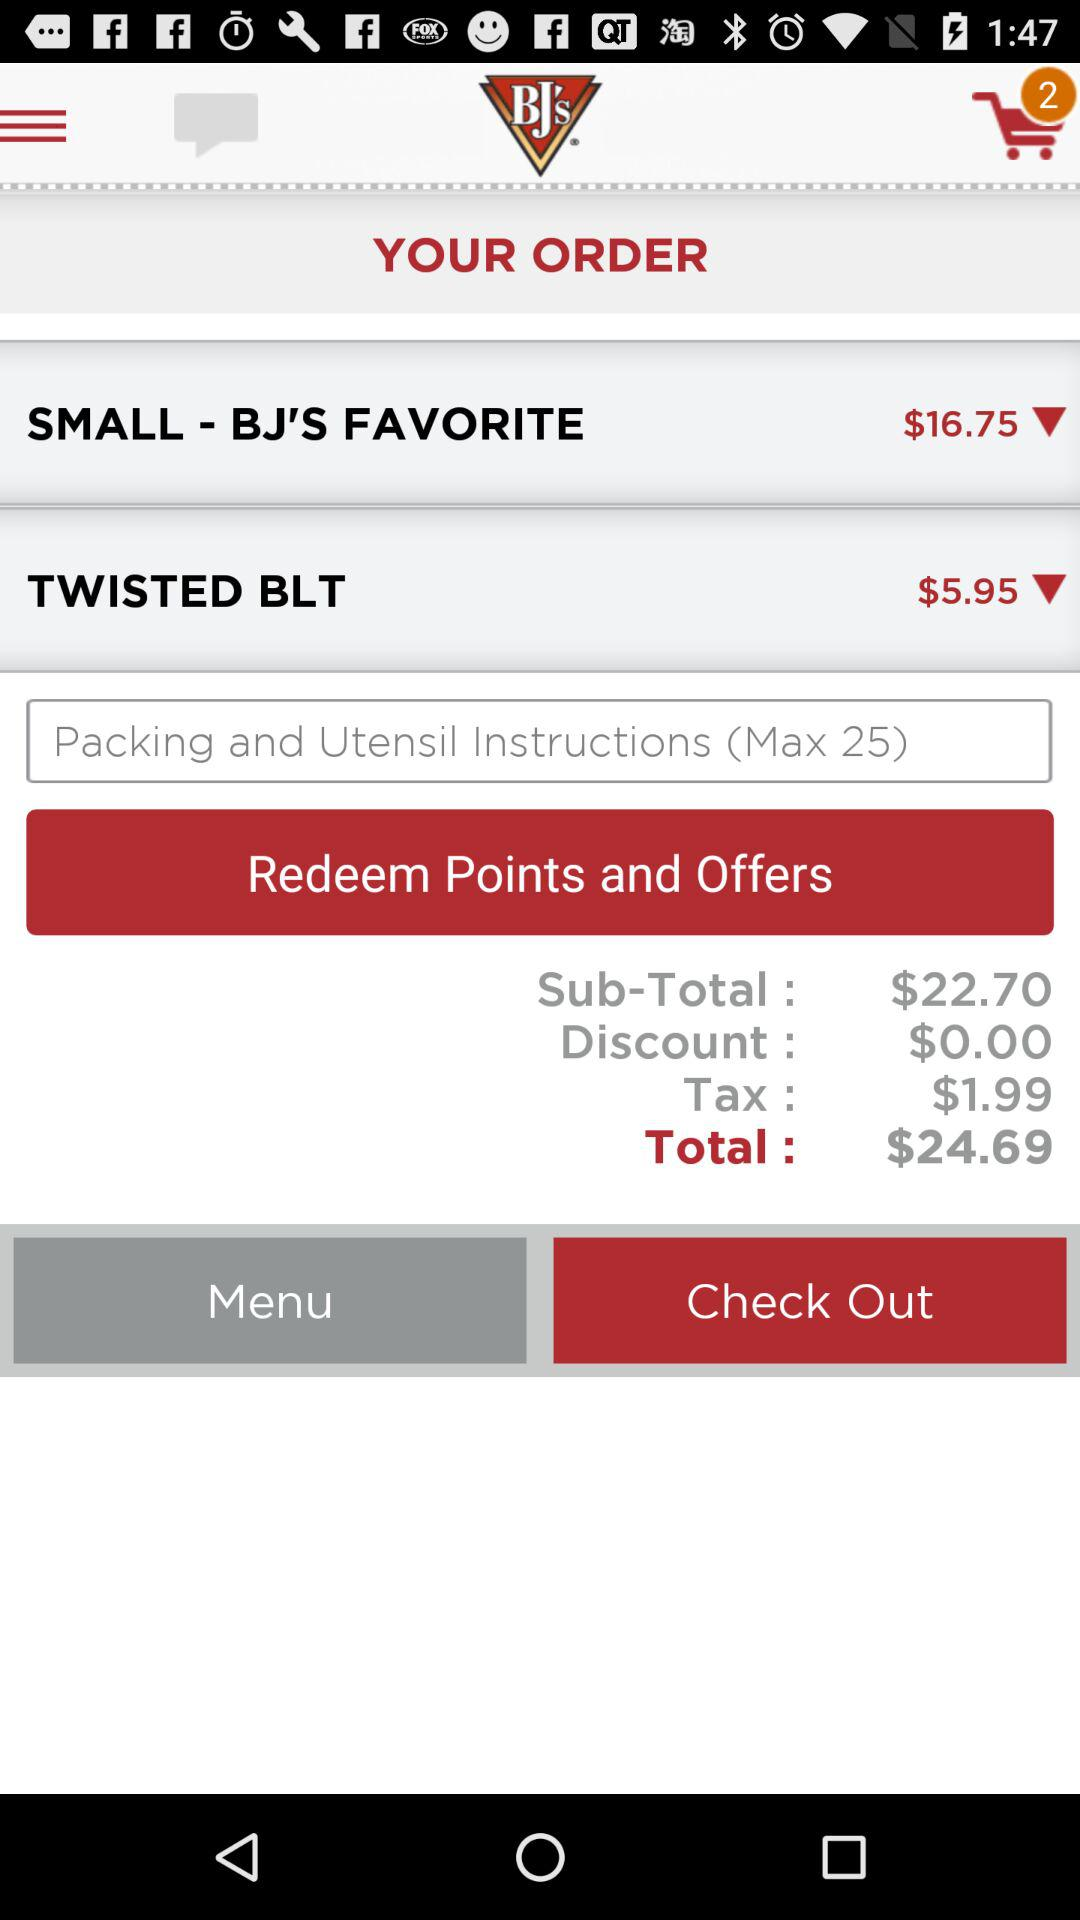How much is the subtotal? The subtotal is $22.70. 